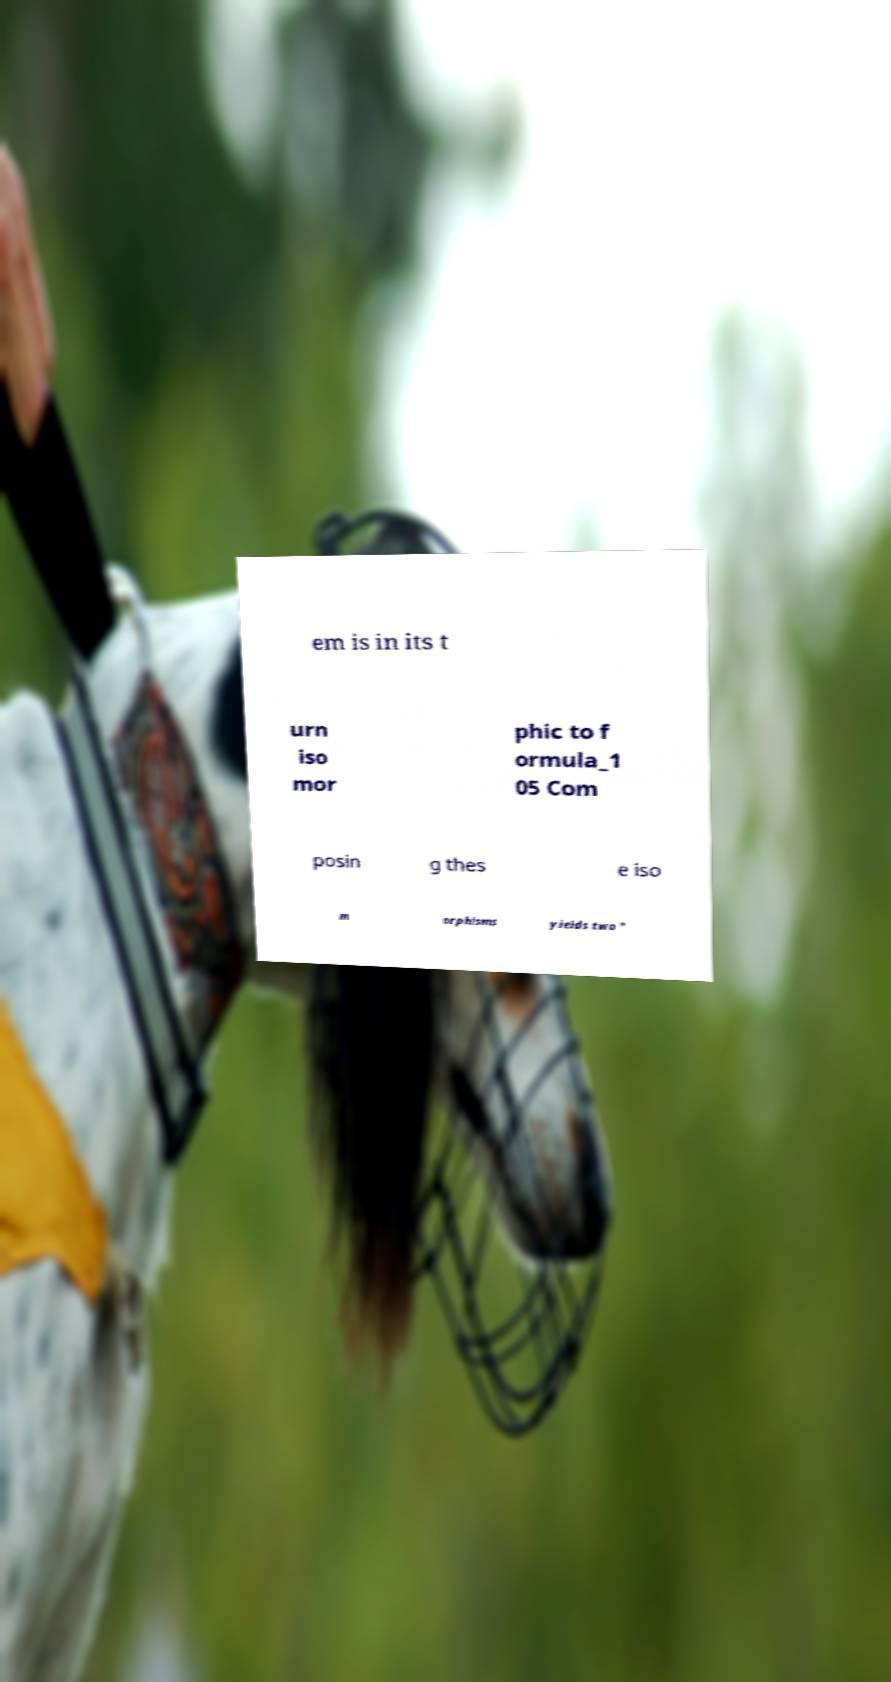Please read and relay the text visible in this image. What does it say? em is in its t urn iso mor phic to f ormula_1 05 Com posin g thes e iso m orphisms yields two " 